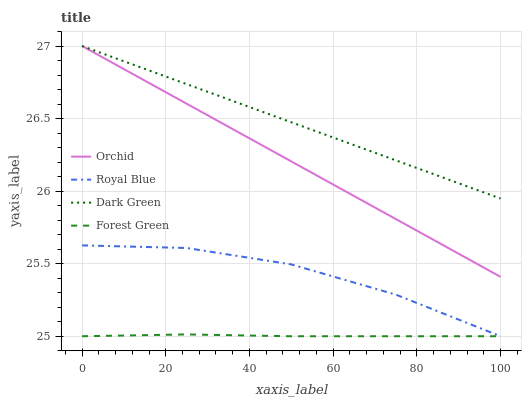Does Forest Green have the minimum area under the curve?
Answer yes or no. Yes. Does Dark Green have the maximum area under the curve?
Answer yes or no. Yes. Does Dark Green have the minimum area under the curve?
Answer yes or no. No. Does Forest Green have the maximum area under the curve?
Answer yes or no. No. Is Dark Green the smoothest?
Answer yes or no. Yes. Is Royal Blue the roughest?
Answer yes or no. Yes. Is Forest Green the smoothest?
Answer yes or no. No. Is Forest Green the roughest?
Answer yes or no. No. Does Royal Blue have the lowest value?
Answer yes or no. Yes. Does Dark Green have the lowest value?
Answer yes or no. No. Does Orchid have the highest value?
Answer yes or no. Yes. Does Forest Green have the highest value?
Answer yes or no. No. Is Royal Blue less than Dark Green?
Answer yes or no. Yes. Is Orchid greater than Forest Green?
Answer yes or no. Yes. Does Royal Blue intersect Forest Green?
Answer yes or no. Yes. Is Royal Blue less than Forest Green?
Answer yes or no. No. Is Royal Blue greater than Forest Green?
Answer yes or no. No. Does Royal Blue intersect Dark Green?
Answer yes or no. No. 